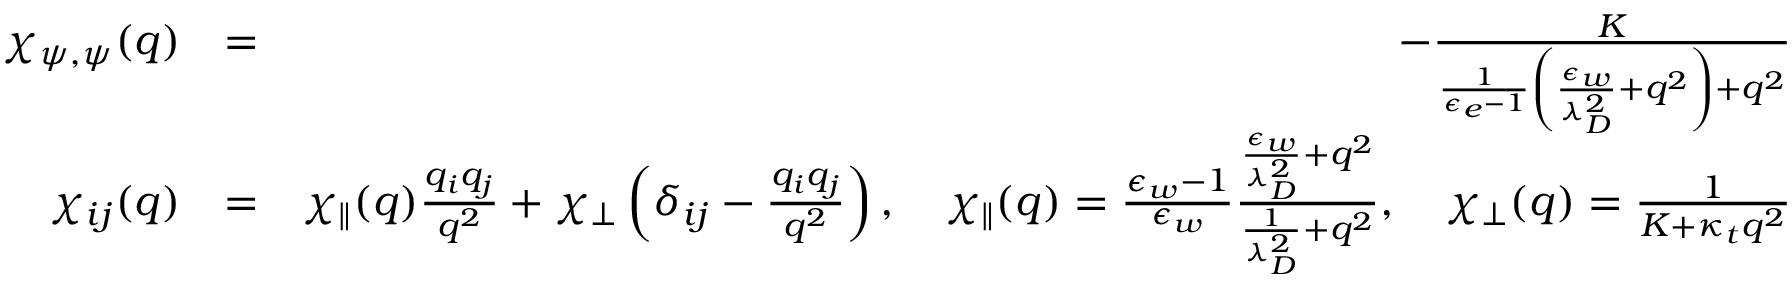<formula> <loc_0><loc_0><loc_500><loc_500>\begin{array} { r l r } { \chi _ { \psi , \psi } ( q ) } & { = } & { - \frac { K } { \frac { 1 } { \epsilon _ { e } - 1 } \left ( \frac { \epsilon _ { w } } { \lambda _ { D } ^ { 2 } } + q ^ { 2 } \right ) + q ^ { 2 } } } \\ { \chi _ { i j } ( q ) } & { = } & { \chi _ { \| } ( q ) \frac { q _ { i } q _ { j } } { q ^ { 2 } } + \chi _ { \perp } \left ( \delta _ { i j } - \frac { q _ { i } q _ { j } } { q ^ { 2 } } \right ) , \quad \chi _ { \| } ( q ) = \frac { \epsilon _ { w } - 1 } { \epsilon _ { w } } \frac { \frac { \epsilon _ { w } } { \lambda _ { D } ^ { 2 } } + q ^ { 2 } } { \frac { 1 } { \lambda _ { D } ^ { 2 } } + q ^ { 2 } } , \quad \chi _ { \perp } ( q ) = \frac { 1 } { K + \kappa _ { t } q ^ { 2 } } } \end{array}</formula> 